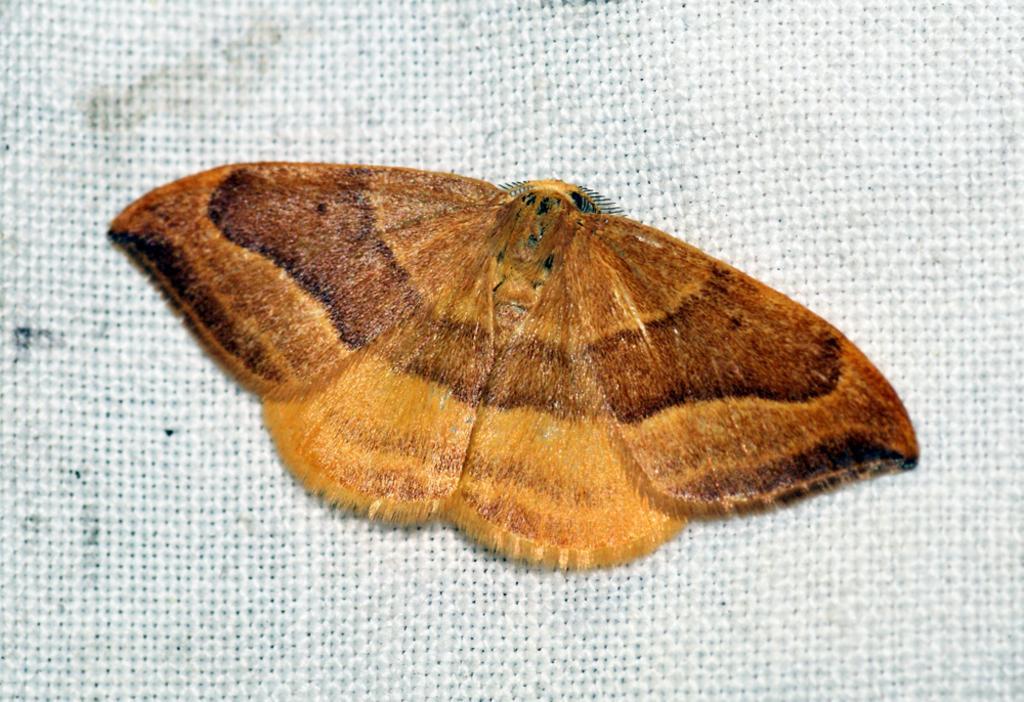Can you describe this image briefly? In this picture there is a brown color butterfly sitting on the white color jute cloth. 